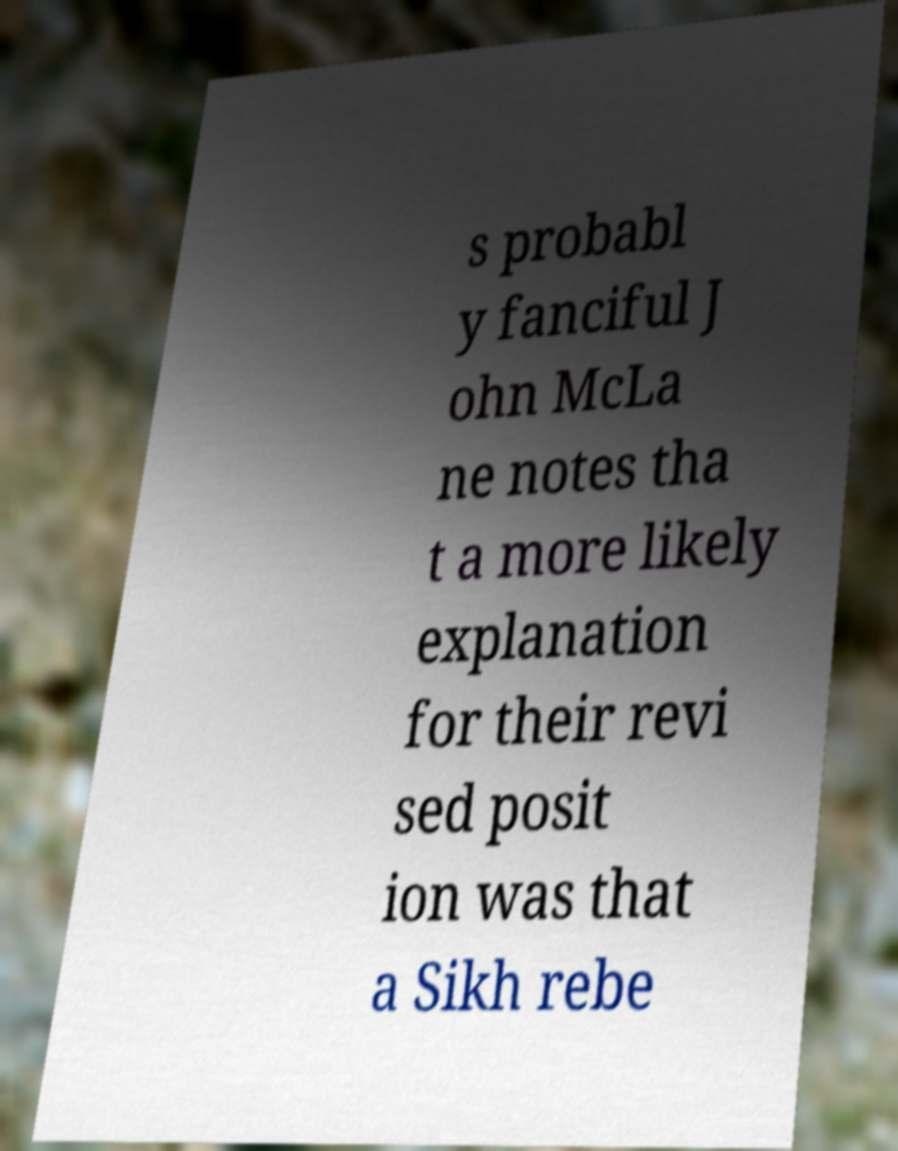Can you accurately transcribe the text from the provided image for me? s probabl y fanciful J ohn McLa ne notes tha t a more likely explanation for their revi sed posit ion was that a Sikh rebe 